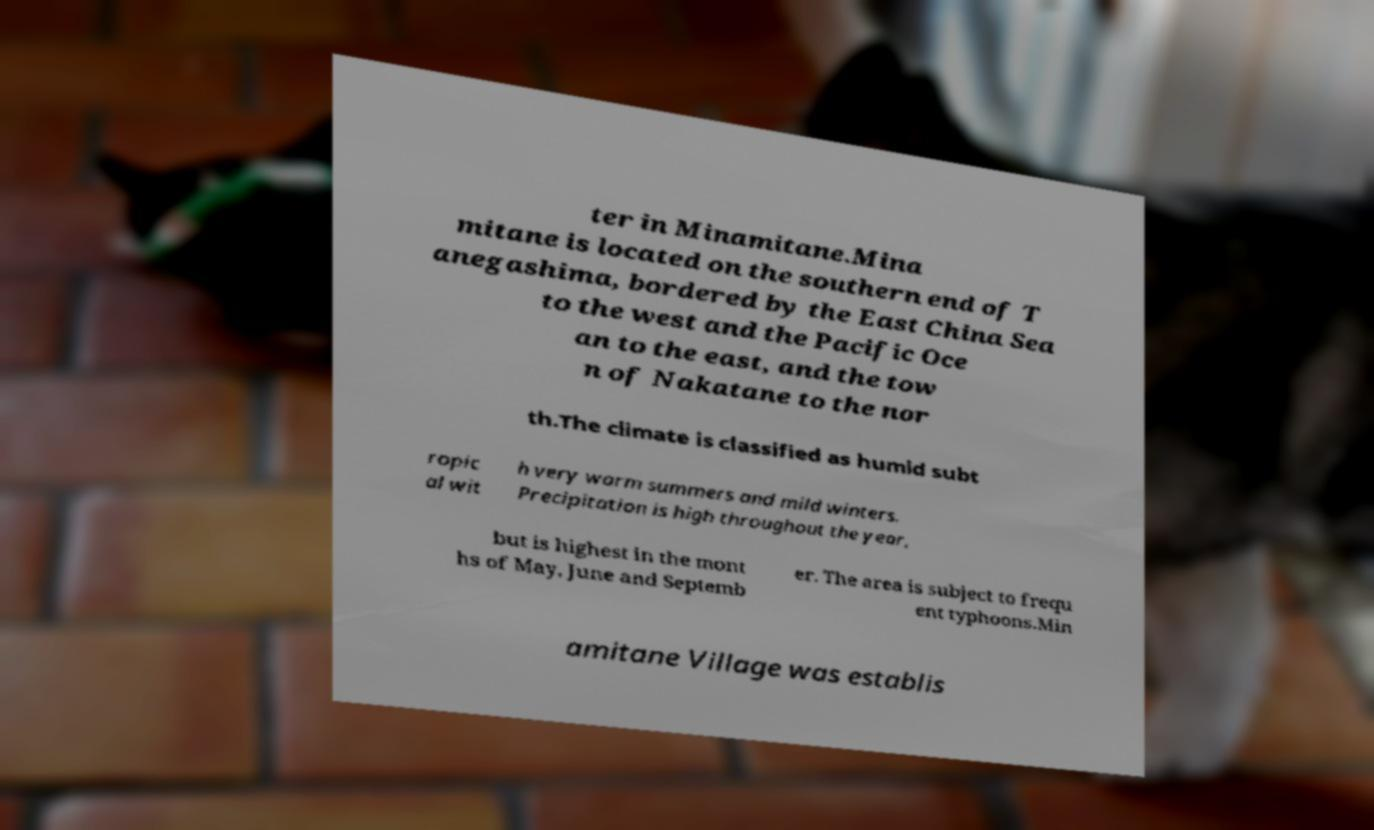Could you assist in decoding the text presented in this image and type it out clearly? ter in Minamitane.Mina mitane is located on the southern end of T anegashima, bordered by the East China Sea to the west and the Pacific Oce an to the east, and the tow n of Nakatane to the nor th.The climate is classified as humid subt ropic al wit h very warm summers and mild winters. Precipitation is high throughout the year, but is highest in the mont hs of May, June and Septemb er. The area is subject to frequ ent typhoons.Min amitane Village was establis 